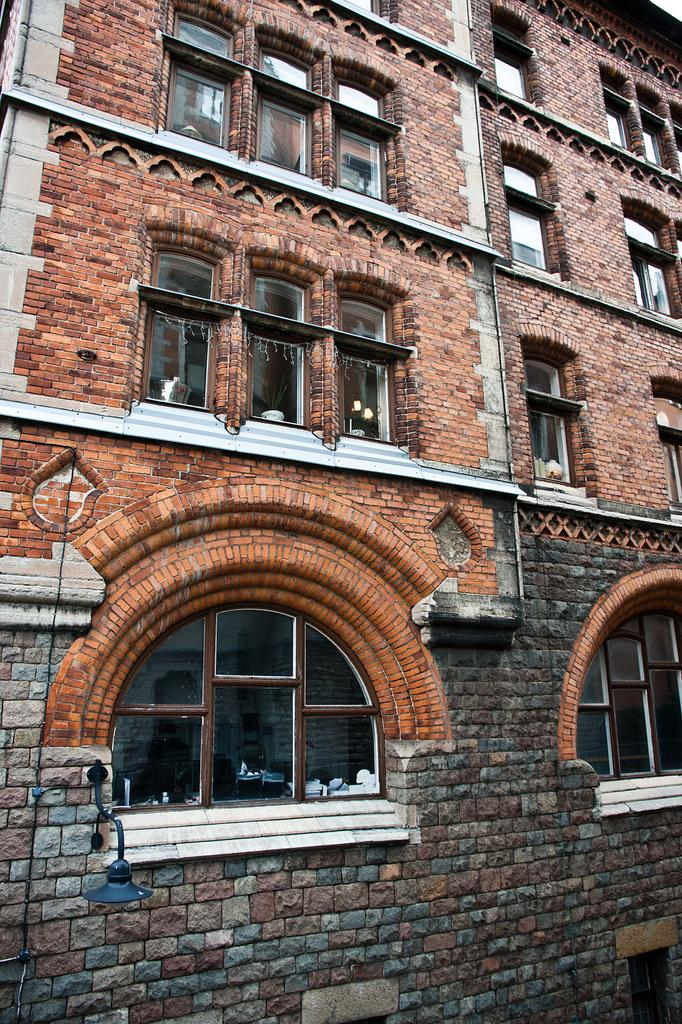What is the main subject of the image? The main subject of the image is a building. How is the building positioned in the image? The image is a front view of the building. What type of windows does the building have? The building has glass windows. Can you see a kite flying in the image? No, there is no kite present in the image. Is there any motion or movement happening in the image? The image is a still photograph, so there is no motion or movement visible. 